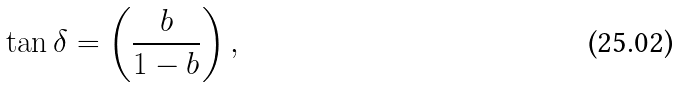<formula> <loc_0><loc_0><loc_500><loc_500>\tan \delta = \left ( \frac { b } { 1 - b } \right ) ,</formula> 